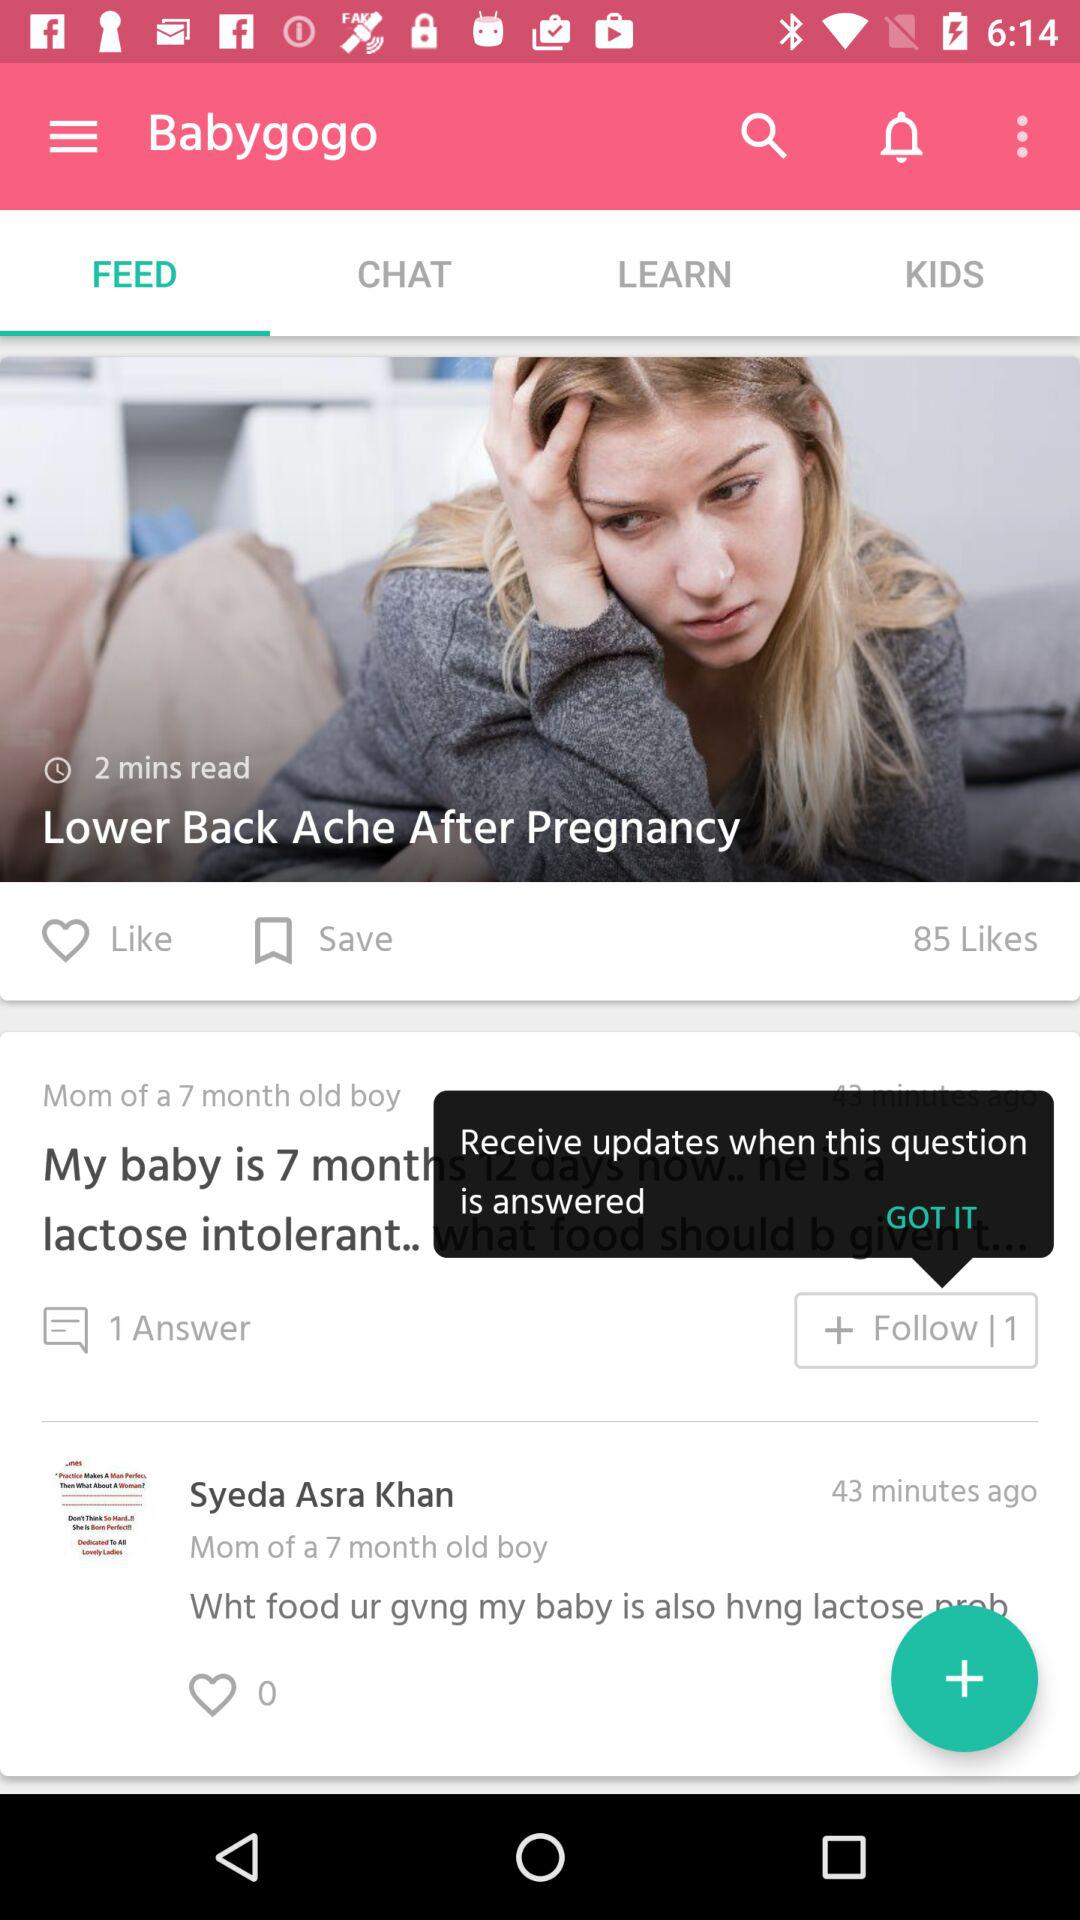How many likes are there? There are 85 likes. 